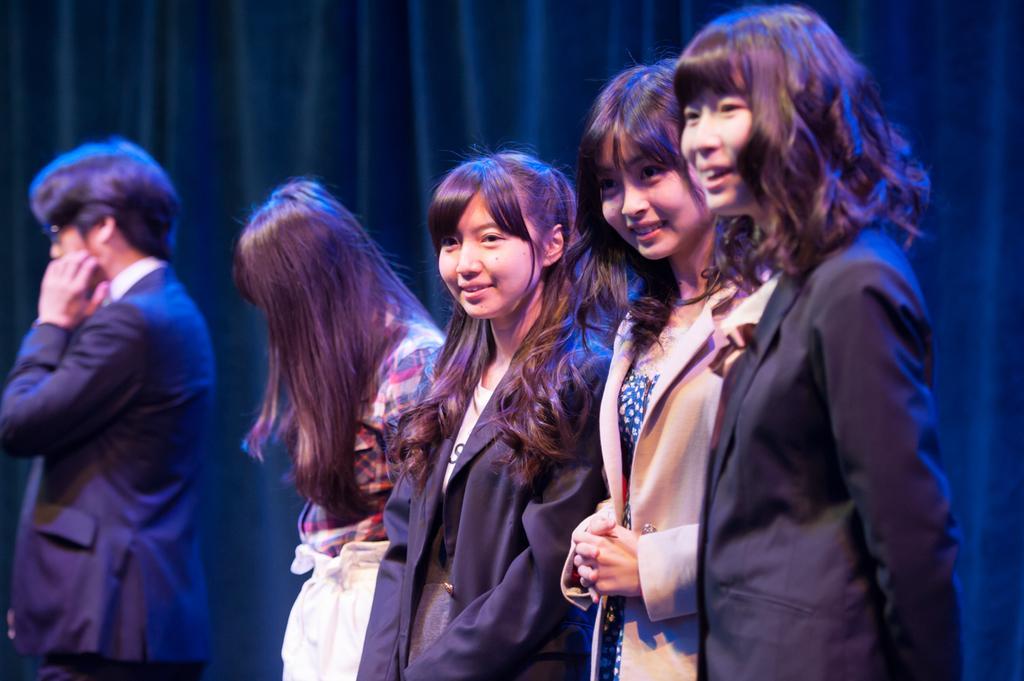In one or two sentences, can you explain what this image depicts? In the picture we can see there are four girls and a man standing, they are wearing clothes and among them three girls are smiling. Behind them there is curtains. 